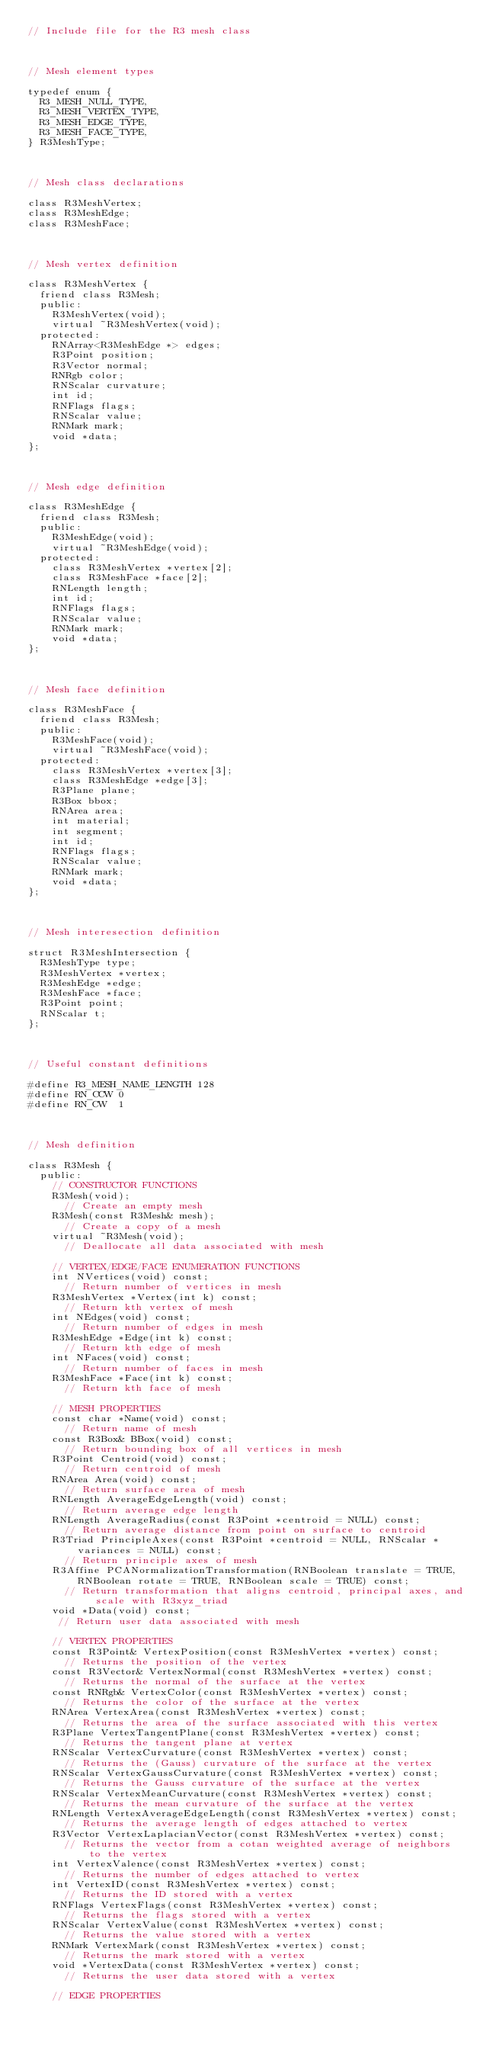Convert code to text. <code><loc_0><loc_0><loc_500><loc_500><_C_>// Include file for the R3 mesh class 



// Mesh element types

typedef enum {
  R3_MESH_NULL_TYPE,
  R3_MESH_VERTEX_TYPE,
  R3_MESH_EDGE_TYPE,
  R3_MESH_FACE_TYPE,
} R3MeshType;



// Mesh class declarations

class R3MeshVertex;
class R3MeshEdge;
class R3MeshFace;



// Mesh vertex definition

class R3MeshVertex {
  friend class R3Mesh;
  public:
    R3MeshVertex(void);
    virtual ~R3MeshVertex(void);
  protected:
    RNArray<R3MeshEdge *> edges;
    R3Point position;
    R3Vector normal;
    RNRgb color;
    RNScalar curvature;
    int id;
    RNFlags flags;
    RNScalar value;
    RNMark mark;
    void *data;
};
  
  
  
// Mesh edge definition

class R3MeshEdge {
  friend class R3Mesh;
  public:
    R3MeshEdge(void);
    virtual ~R3MeshEdge(void);
  protected:
    class R3MeshVertex *vertex[2];
    class R3MeshFace *face[2];
    RNLength length;
    int id;
    RNFlags flags;
    RNScalar value;
    RNMark mark;
    void *data;
};
  


// Mesh face definition

class R3MeshFace {
  friend class R3Mesh;
  public:
    R3MeshFace(void);
    virtual ~R3MeshFace(void);
  protected:
    class R3MeshVertex *vertex[3];
    class R3MeshEdge *edge[3];
    R3Plane plane;
    R3Box bbox;
    RNArea area;
    int material;
    int segment;
    int id;
    RNFlags flags;
    RNScalar value;
    RNMark mark;
    void *data;
};



// Mesh interesection definition

struct R3MeshIntersection {
  R3MeshType type;
  R3MeshVertex *vertex;
  R3MeshEdge *edge;
  R3MeshFace *face;
  R3Point point;
  RNScalar t;
};
  
  

// Useful constant definitions 

#define R3_MESH_NAME_LENGTH 128
#define RN_CCW 0
#define RN_CW  1 



// Mesh definition 

class R3Mesh {
  public:
    // CONSTRUCTOR FUNCTIONS
    R3Mesh(void);
      // Create an empty mesh
    R3Mesh(const R3Mesh& mesh);
      // Create a copy of a mesh
    virtual ~R3Mesh(void);
      // Deallocate all data associated with mesh

    // VERTEX/EDGE/FACE ENUMERATION FUNCTIONS
    int NVertices(void) const;
      // Return number of vertices in mesh
    R3MeshVertex *Vertex(int k) const;
      // Return kth vertex of mesh
    int NEdges(void) const;
      // Return number of edges in mesh
    R3MeshEdge *Edge(int k) const;
      // Return kth edge of mesh
    int NFaces(void) const;
      // Return number of faces in mesh
    R3MeshFace *Face(int k) const;
      // Return kth face of mesh

    // MESH PROPERTIES
    const char *Name(void) const;
      // Return name of mesh
    const R3Box& BBox(void) const;
      // Return bounding box of all vertices in mesh
    R3Point Centroid(void) const;
      // Return centroid of mesh
    RNArea Area(void) const;
      // Return surface area of mesh
    RNLength AverageEdgeLength(void) const;
      // Return average edge length
    RNLength AverageRadius(const R3Point *centroid = NULL) const;
      // Return average distance from point on surface to centroid
    R3Triad PrincipleAxes(const R3Point *centroid = NULL, RNScalar *variances = NULL) const;
      // Return principle axes of mesh
    R3Affine PCANormalizationTransformation(RNBoolean translate = TRUE, RNBoolean rotate = TRUE, RNBoolean scale = TRUE) const;
      // Return transformation that aligns centroid, principal axes, and scale with R3xyz_triad
    void *Data(void) const;
     // Return user data associated with mesh

    // VERTEX PROPERTIES
    const R3Point& VertexPosition(const R3MeshVertex *vertex) const;
      // Returns the position of the vertex
    const R3Vector& VertexNormal(const R3MeshVertex *vertex) const;
      // Returns the normal of the surface at the vertex
    const RNRgb& VertexColor(const R3MeshVertex *vertex) const;
      // Returns the color of the surface at the vertex
    RNArea VertexArea(const R3MeshVertex *vertex) const;
      // Returns the area of the surface associated with this vertex
    R3Plane VertexTangentPlane(const R3MeshVertex *vertex) const;
      // Returns the tangent plane at vertex 
    RNScalar VertexCurvature(const R3MeshVertex *vertex) const;
      // Returns the (Gauss) curvature of the surface at the vertex
    RNScalar VertexGaussCurvature(const R3MeshVertex *vertex) const;
      // Returns the Gauss curvature of the surface at the vertex
    RNScalar VertexMeanCurvature(const R3MeshVertex *vertex) const;
      // Returns the mean curvature of the surface at the vertex
    RNLength VertexAverageEdgeLength(const R3MeshVertex *vertex) const;
      // Returns the average length of edges attached to vertex
    R3Vector VertexLaplacianVector(const R3MeshVertex *vertex) const;
      // Returns the vector from a cotan weighted average of neighbors to the vertex
    int VertexValence(const R3MeshVertex *vertex) const;
      // Returns the number of edges attached to vertex
    int VertexID(const R3MeshVertex *vertex) const;
      // Returns the ID stored with a vertex
    RNFlags VertexFlags(const R3MeshVertex *vertex) const;
      // Returns the flags stored with a vertex
    RNScalar VertexValue(const R3MeshVertex *vertex) const;
      // Returns the value stored with a vertex
    RNMark VertexMark(const R3MeshVertex *vertex) const;
      // Returns the mark stored with a vertex
    void *VertexData(const R3MeshVertex *vertex) const;
      // Returns the user data stored with a vertex
  
    // EDGE PROPERTIES</code> 